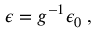<formula> <loc_0><loc_0><loc_500><loc_500>\epsilon = g ^ { - 1 } \epsilon _ { 0 } \, ,</formula> 